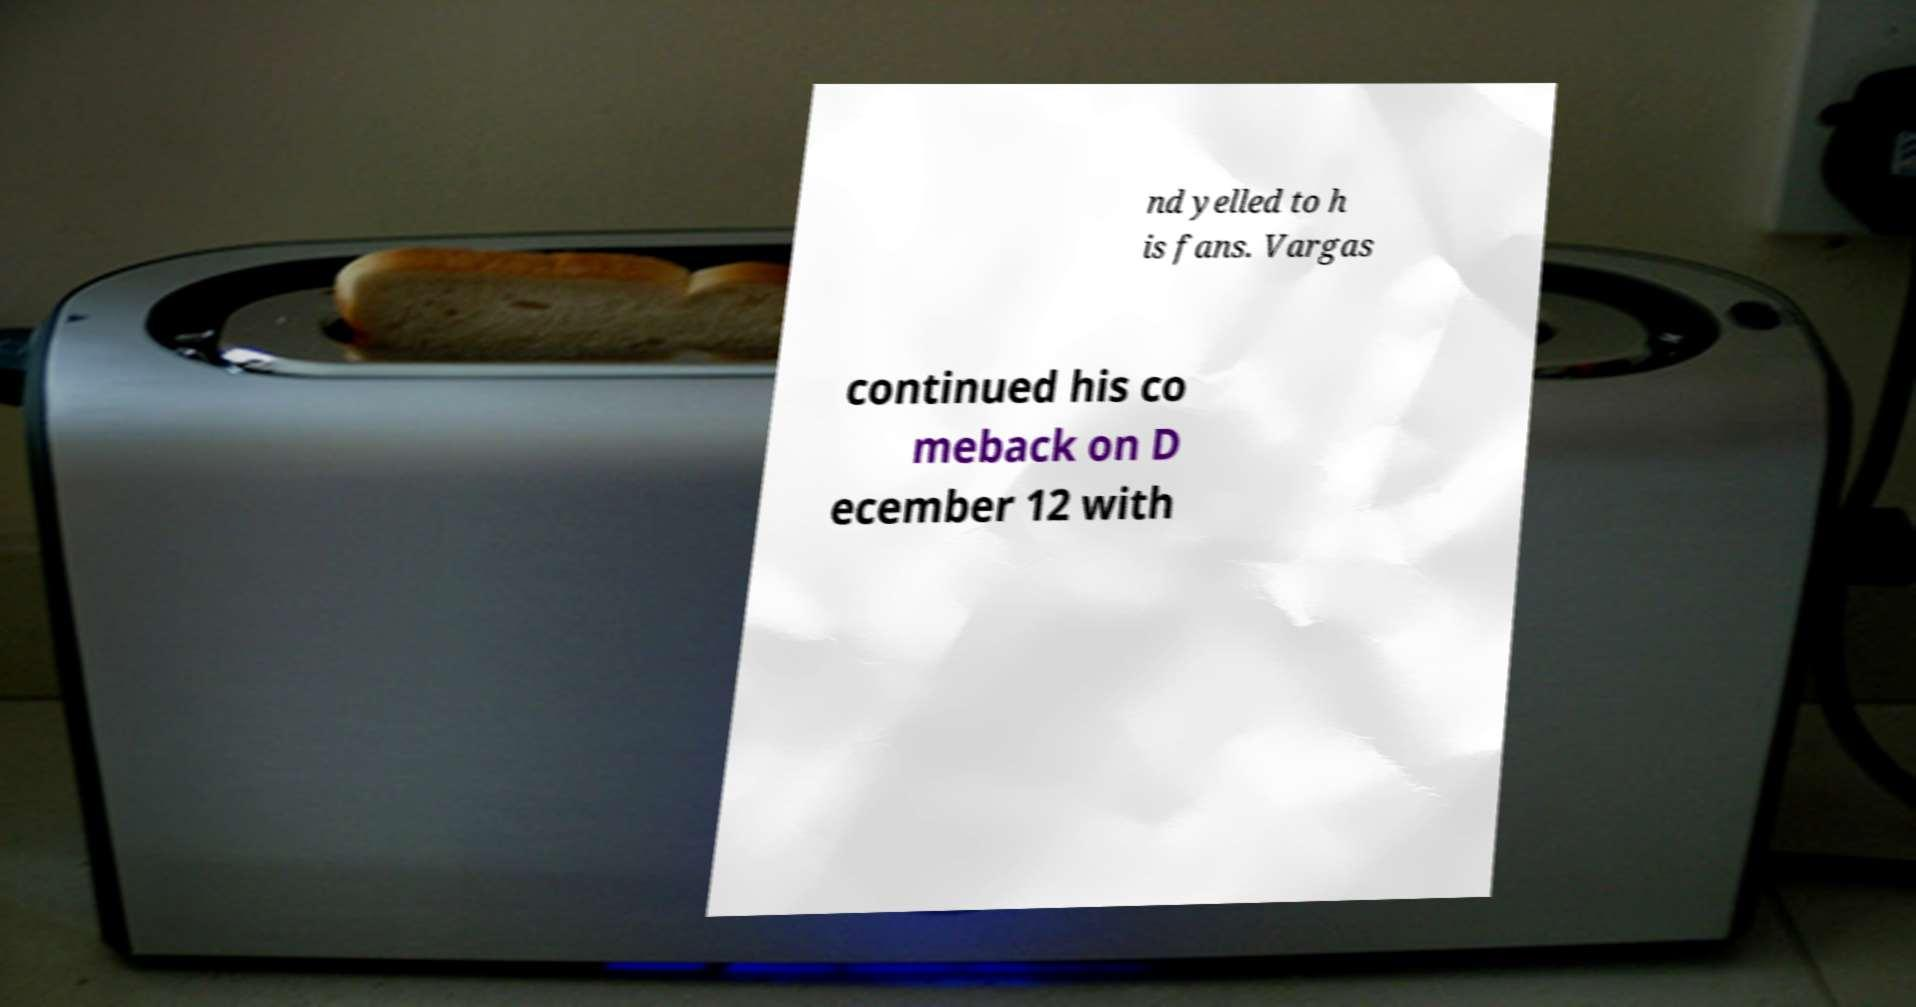What messages or text are displayed in this image? I need them in a readable, typed format. nd yelled to h is fans. Vargas continued his co meback on D ecember 12 with 